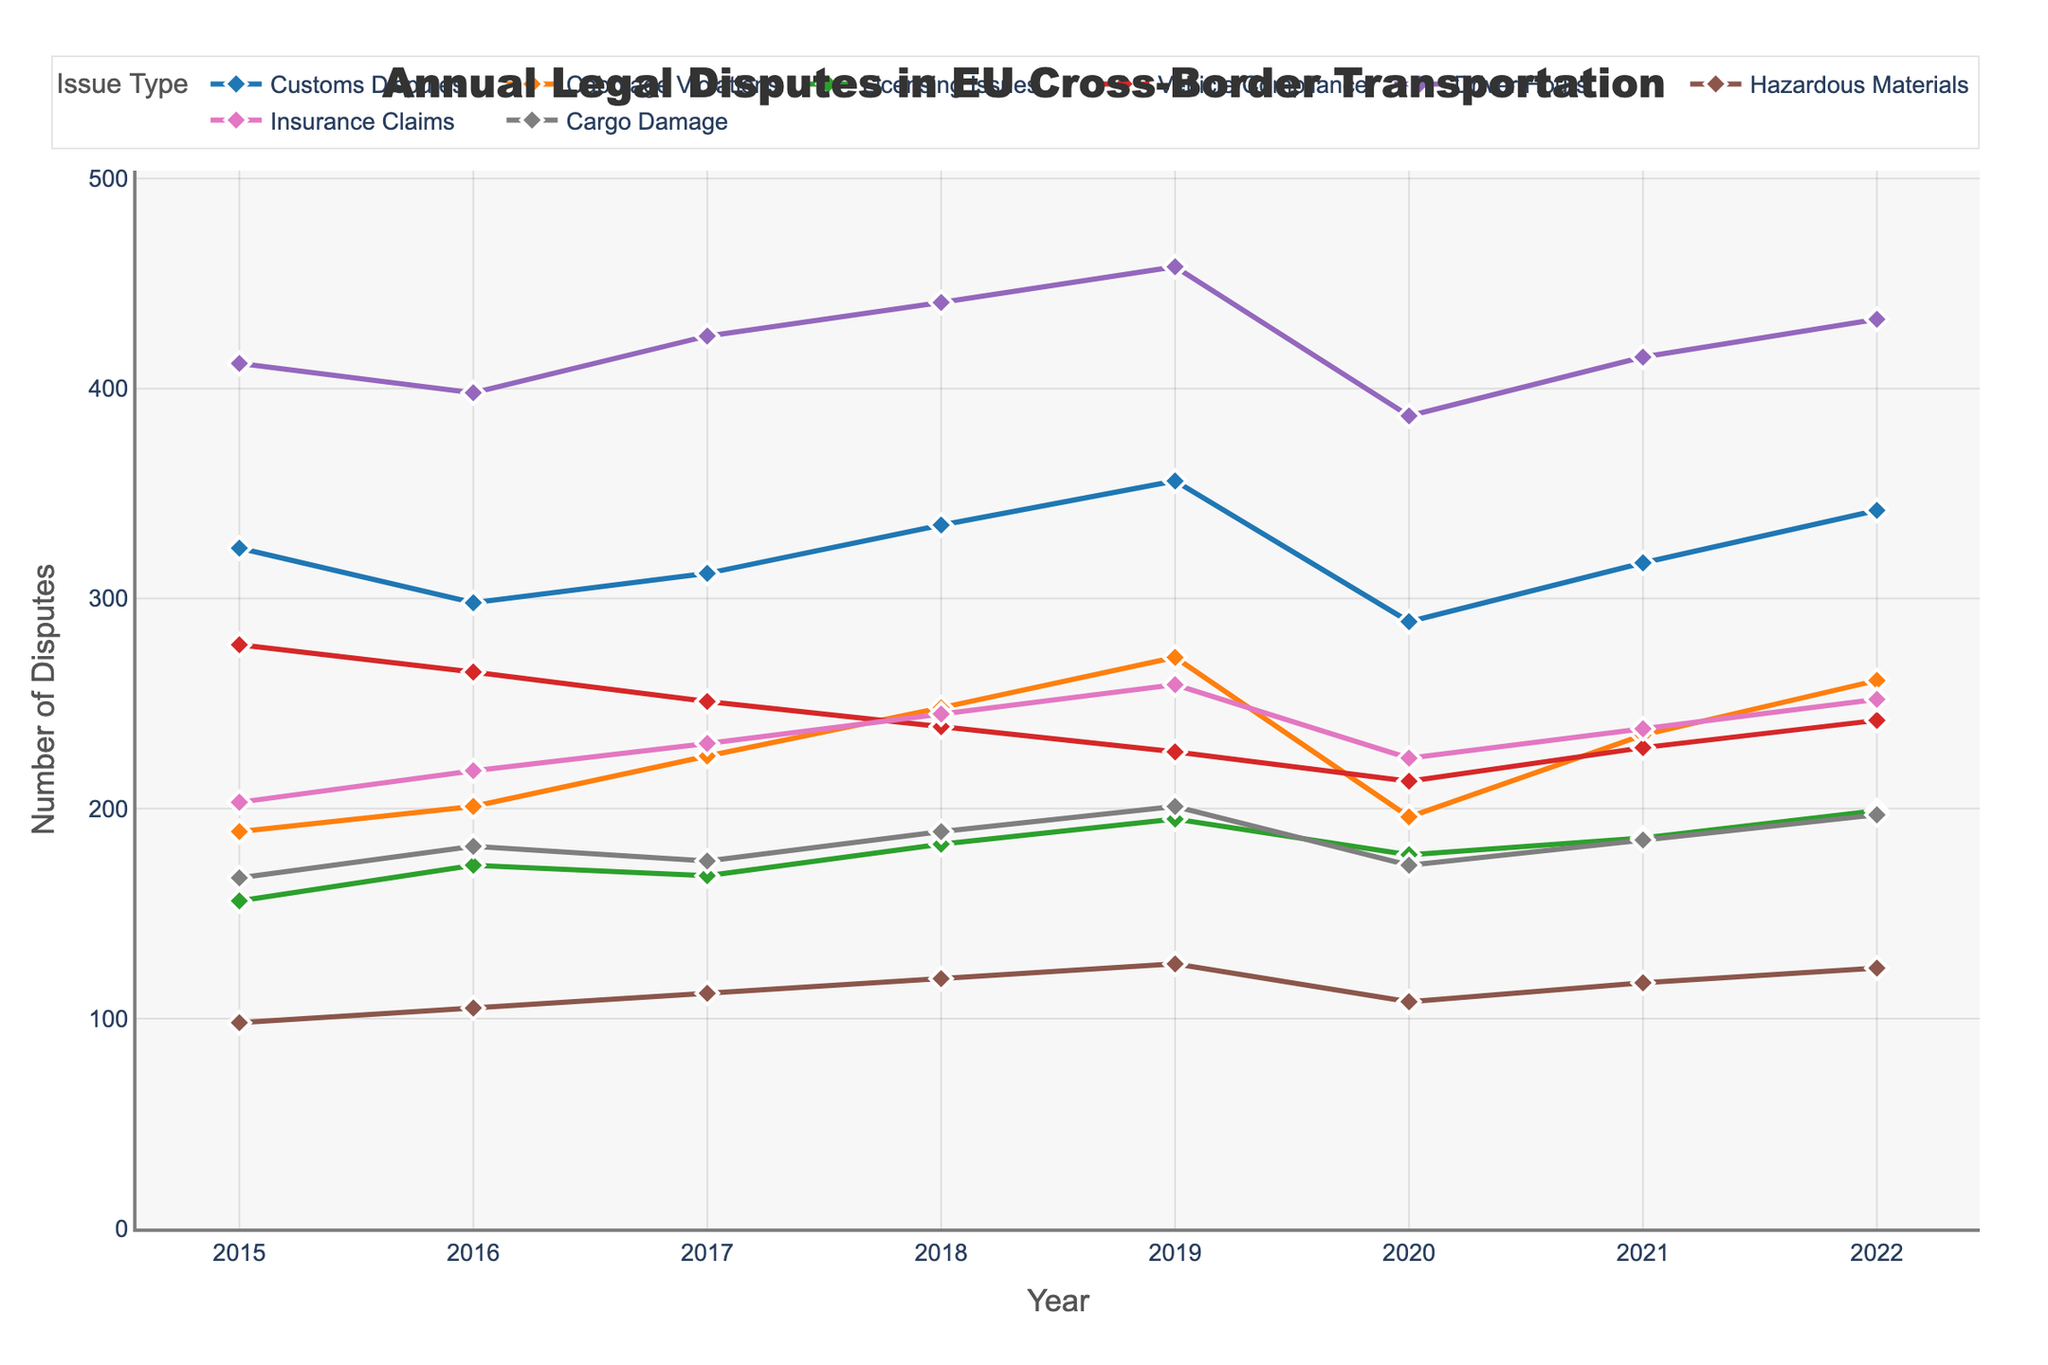Which issue type had the highest number of disputes in 2019? To answer this, look at the year 2019 and identify the issue type with the highest value. Vehicle Compliance had 458 disputes, which is the highest.
Answer: Vehicle Compliance What is the overall trend of Customs Disputes between 2015 and 2022? Observe the plot line for Customs Disputes across the years from 2015 to 2022. Customs Disputes increased steadily from 2015 to 2019, then dropped in 2020, and rose again in 2021 and 2022.
Answer: Mostly increasing with a dip in 2020 How did the number of Insurance Claims disputes change between 2018 and 2022? Look at the Insurance Claims line between 2018 and 2022. The number increases from 245 in 2018 to 252 in 2022.
Answer: Increased Which issue saw the greatest increase in the number of disputes from 2015 to 2019? Compare the number of disputes for all issue types between 2015 and 2019. Driver Hours increased from 412 in 2015 to 458 in 2019, the greatest increase of 46 disputes.
Answer: Driver Hours What is the average number of Cargo Damage disputes from 2017 to 2020? Calculate the average of Cargo Damage disputes from 2017 to 2020: (175 + 189 + 201 + 173) / 4 = 184.5.
Answer: 184.5 Which two issue types had the closest number of disputes in 2020? Compare the 2020 values for all issue types. Insurance Claims and Cabotage Violations had 224 and 196 disputes, respectively, showing the closest proximity.
Answer: Insurance Claims and Cabotage Violations Was the trend of Licensing Issues disputes mostly increasing, decreasing, or stable from 2015 to 2022? Look at the trend of Licensing Issues from 2015 to 2022. Although there are ups and downs, generally, the trend has been slightly increasing over time.
Answer: Mostly increasing By how much did Hazardous Materials disputes increase from 2015 to 2020? Subtract the number of disputes in 2015 (98) from the number in 2020 (108): 108 - 98 = 10.
Answer: 10 Which issue type had the largest decrease in disputes from 2019 to 2020? Compare the decrease in disputes for each issue type between 2019 and 2020. Customs Disputes decreased from 356 to 289, the largest drop of 67 disputes.
Answer: Customs Disputes 